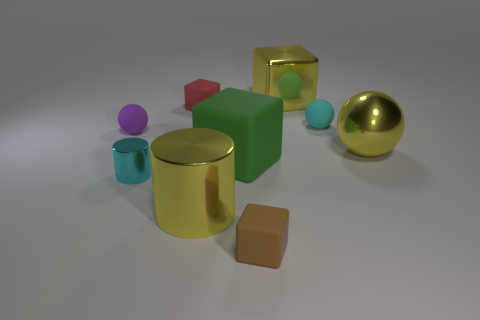Add 1 tiny brown objects. How many objects exist? 10 Subtract all blocks. How many objects are left? 5 Subtract 1 green cubes. How many objects are left? 8 Subtract all cyan metallic cylinders. Subtract all small cyan rubber balls. How many objects are left? 7 Add 6 tiny cylinders. How many tiny cylinders are left? 7 Add 9 big green matte blocks. How many big green matte blocks exist? 10 